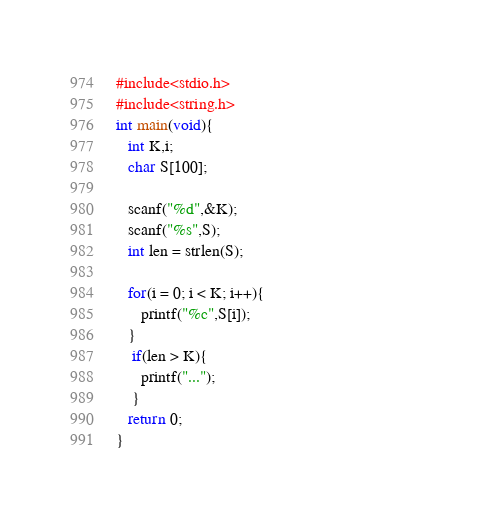<code> <loc_0><loc_0><loc_500><loc_500><_C_>#include<stdio.h>                                                 
#include<string.h>                                                
int main(void){                                                   
   int K,i;                                                       
   char S[100];                                                   
                                                                  
   scanf("%d",&K);                                                
   scanf("%s",S);                                                 
   int len = strlen(S);                                           
                                                                  
   for(i = 0; i < K; i++){                                        
      printf("%c",S[i]);                                          
   }                                                              
    if(len > K){                                                  
      printf("...");                                              
    }                                                             
   return 0;                                                      
}     </code> 